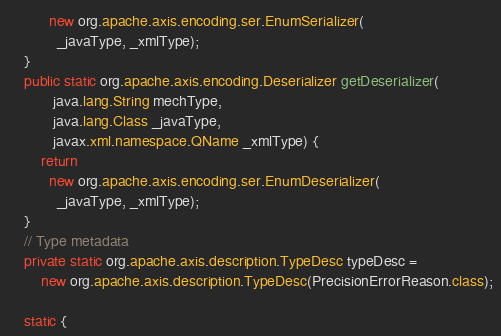<code> <loc_0><loc_0><loc_500><loc_500><_Java_>          new org.apache.axis.encoding.ser.EnumSerializer(
            _javaType, _xmlType);
    }
    public static org.apache.axis.encoding.Deserializer getDeserializer(
           java.lang.String mechType, 
           java.lang.Class _javaType,  
           javax.xml.namespace.QName _xmlType) {
        return 
          new org.apache.axis.encoding.ser.EnumDeserializer(
            _javaType, _xmlType);
    }
    // Type metadata
    private static org.apache.axis.description.TypeDesc typeDesc =
        new org.apache.axis.description.TypeDesc(PrecisionErrorReason.class);

    static {</code> 